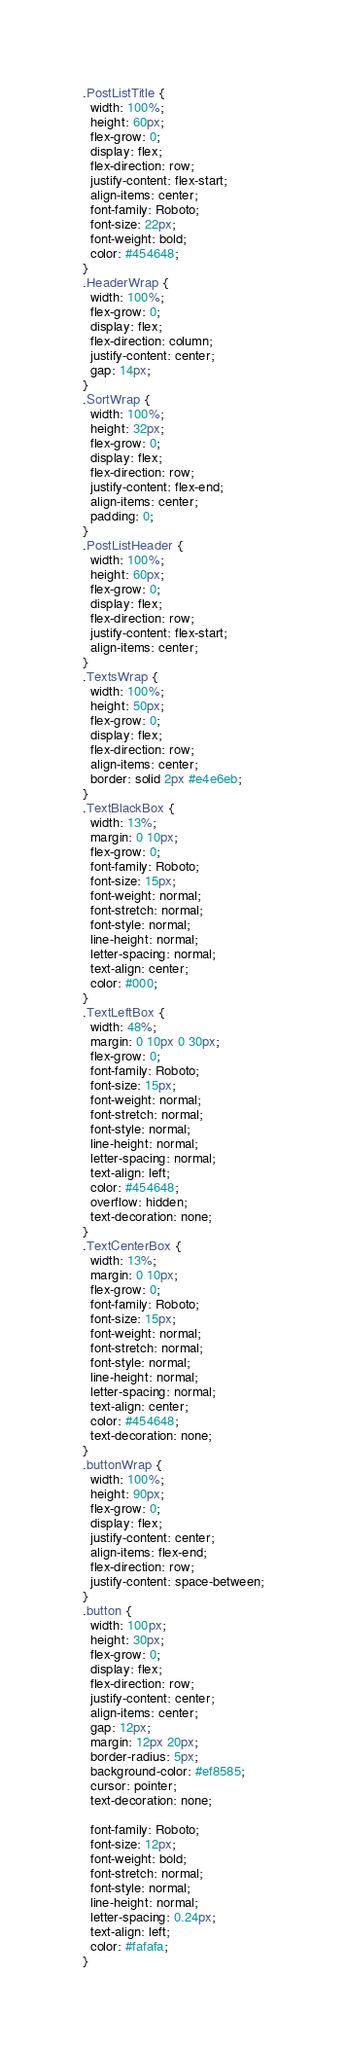Convert code to text. <code><loc_0><loc_0><loc_500><loc_500><_CSS_>.PostListTitle {
  width: 100%;
  height: 60px;
  flex-grow: 0;
  display: flex;
  flex-direction: row;
  justify-content: flex-start;
  align-items: center;
  font-family: Roboto;
  font-size: 22px;
  font-weight: bold;
  color: #454648;
}
.HeaderWrap {
  width: 100%;
  flex-grow: 0;
  display: flex;
  flex-direction: column;
  justify-content: center;
  gap: 14px;
}
.SortWrap {
  width: 100%;
  height: 32px;
  flex-grow: 0;
  display: flex;
  flex-direction: row;
  justify-content: flex-end;
  align-items: center;
  padding: 0;
}
.PostListHeader {
  width: 100%;
  height: 60px;
  flex-grow: 0;
  display: flex;
  flex-direction: row;
  justify-content: flex-start;
  align-items: center;
}
.TextsWrap {
  width: 100%;
  height: 50px;
  flex-grow: 0;
  display: flex;
  flex-direction: row;
  align-items: center;
  border: solid 2px #e4e6eb;
}
.TextBlackBox {
  width: 13%;
  margin: 0 10px;
  flex-grow: 0;
  font-family: Roboto;
  font-size: 15px;
  font-weight: normal;
  font-stretch: normal;
  font-style: normal;
  line-height: normal;
  letter-spacing: normal;
  text-align: center;
  color: #000;
}
.TextLeftBox {
  width: 48%;
  margin: 0 10px 0 30px;
  flex-grow: 0;
  font-family: Roboto;
  font-size: 15px;
  font-weight: normal;
  font-stretch: normal;
  font-style: normal;
  line-height: normal;
  letter-spacing: normal;
  text-align: left;
  color: #454648;
  overflow: hidden;
  text-decoration: none;
}
.TextCenterBox {
  width: 13%;
  margin: 0 10px;
  flex-grow: 0;
  font-family: Roboto;
  font-size: 15px;
  font-weight: normal;
  font-stretch: normal;
  font-style: normal;
  line-height: normal;
  letter-spacing: normal;
  text-align: center;
  color: #454648;
  text-decoration: none;
}
.buttonWrap {
  width: 100%;
  height: 90px;
  flex-grow: 0;
  display: flex;
  justify-content: center;
  align-items: flex-end;
  flex-direction: row;
  justify-content: space-between;
}
.button {
  width: 100px;
  height: 30px;
  flex-grow: 0;
  display: flex;
  flex-direction: row;
  justify-content: center;
  align-items: center;
  gap: 12px;
  margin: 12px 20px;
  border-radius: 5px;
  background-color: #ef8585;
  cursor: pointer;
  text-decoration: none;

  font-family: Roboto;
  font-size: 12px;
  font-weight: bold;
  font-stretch: normal;
  font-style: normal;
  line-height: normal;
  letter-spacing: 0.24px;
  text-align: left;
  color: #fafafa;
}
</code> 